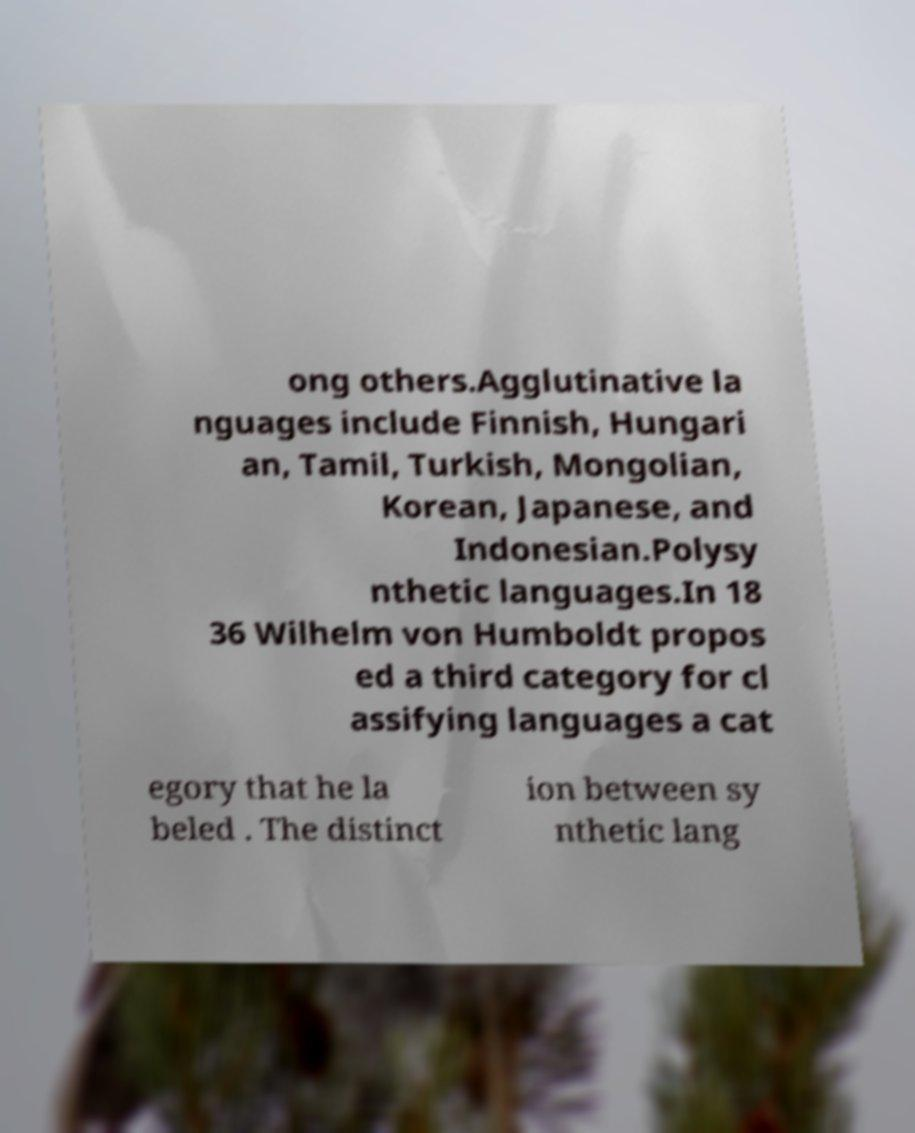Please identify and transcribe the text found in this image. ong others.Agglutinative la nguages include Finnish, Hungari an, Tamil, Turkish, Mongolian, Korean, Japanese, and Indonesian.Polysy nthetic languages.In 18 36 Wilhelm von Humboldt propos ed a third category for cl assifying languages a cat egory that he la beled . The distinct ion between sy nthetic lang 